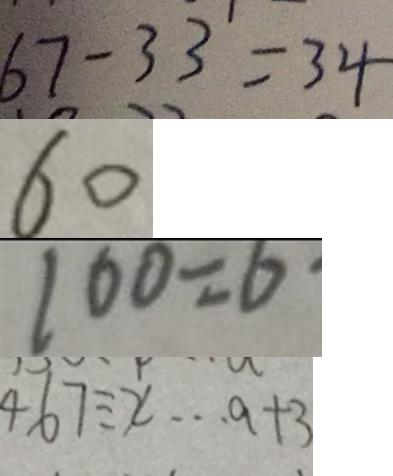Convert formula to latex. <formula><loc_0><loc_0><loc_500><loc_500>6 7 - 3 3 = 3 4 
 6 0 
 1 0 0 = 6 \cdot 
 4 6 7 \div x \cdots a + 3</formula> 